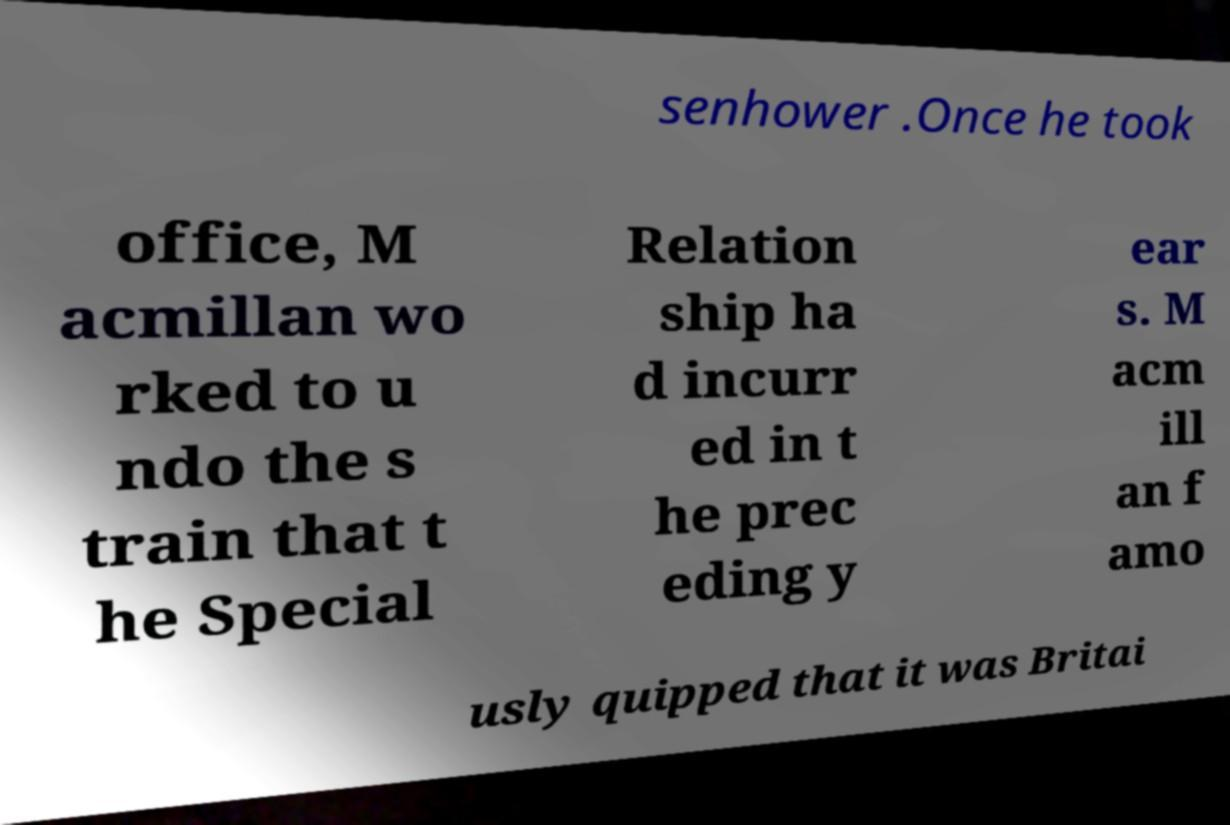Can you accurately transcribe the text from the provided image for me? senhower .Once he took office, M acmillan wo rked to u ndo the s train that t he Special Relation ship ha d incurr ed in t he prec eding y ear s. M acm ill an f amo usly quipped that it was Britai 